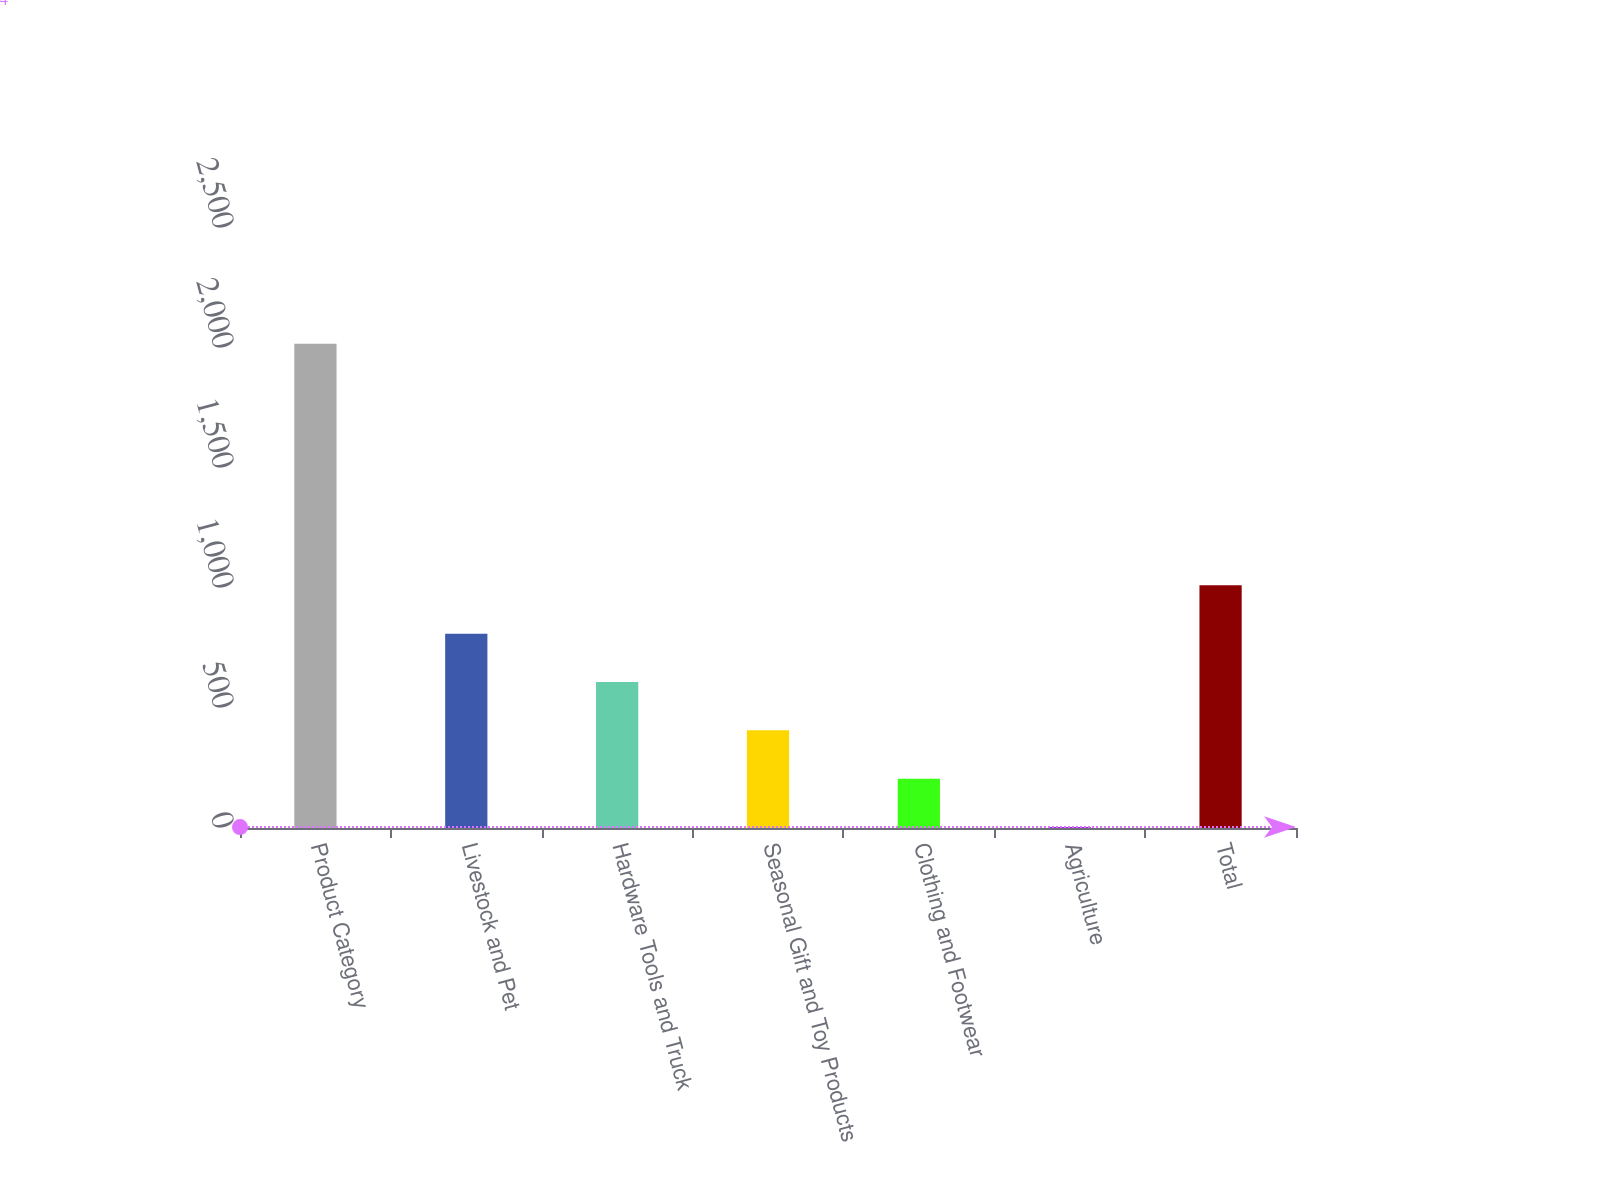Convert chart to OTSL. <chart><loc_0><loc_0><loc_500><loc_500><bar_chart><fcel>Product Category<fcel>Livestock and Pet<fcel>Hardware Tools and Truck<fcel>Seasonal Gift and Toy Products<fcel>Clothing and Footwear<fcel>Agriculture<fcel>Total<nl><fcel>2018<fcel>809.6<fcel>608.2<fcel>406.8<fcel>205.4<fcel>4<fcel>1011<nl></chart> 